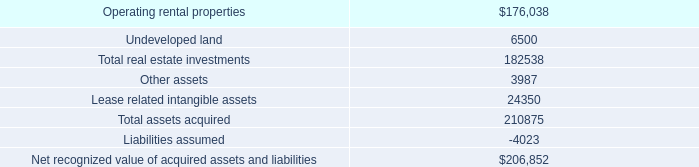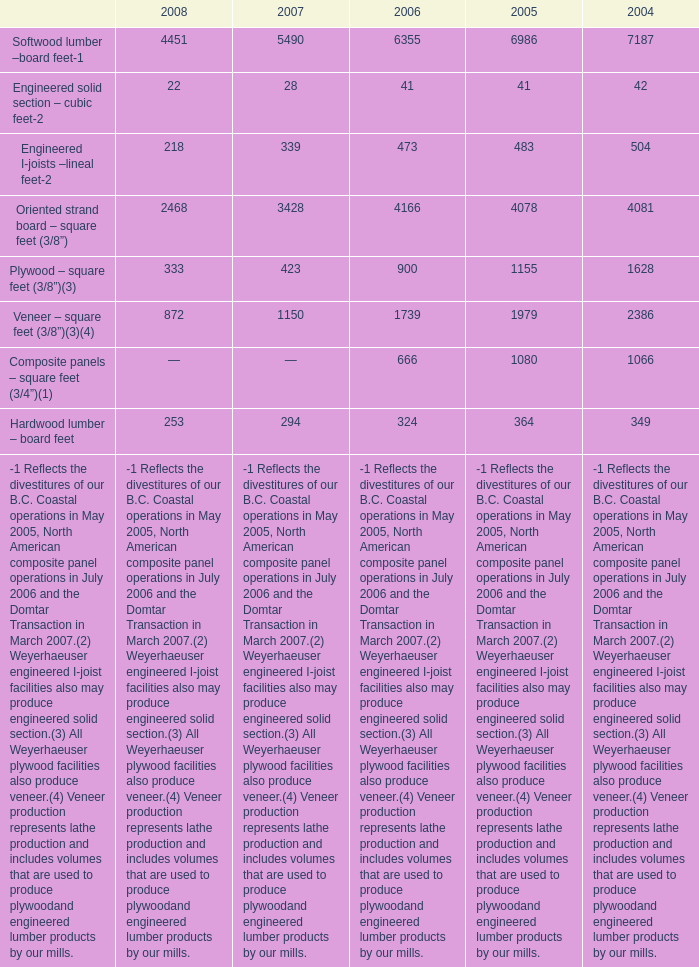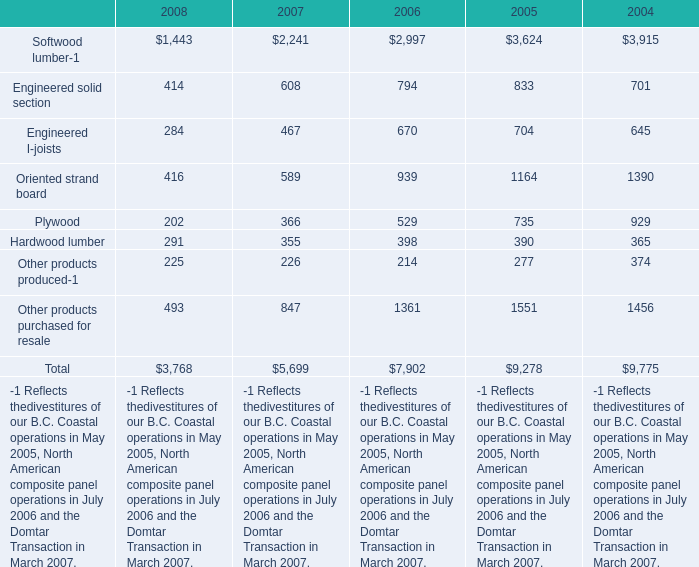What is the sum of the Engineered solid section in the years where Softwood lumber-1 is greater than 3000? 
Computations: (833 + 701)
Answer: 1534.0. 